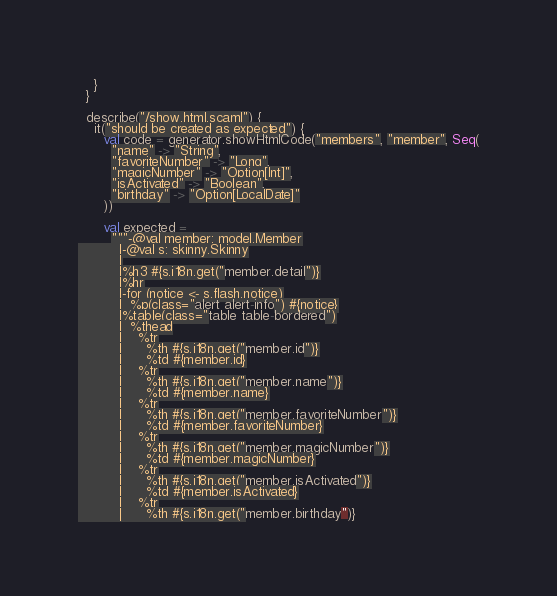<code> <loc_0><loc_0><loc_500><loc_500><_Scala_>    }
  }

  describe("/show.html.scaml") {
    it("should be created as expected") {
      val code = generator.showHtmlCode("members", "member", Seq(
        "name" -> "String",
        "favoriteNumber" -> "Long",
        "magicNumber" -> "Option[Int]",
        "isActivated" -> "Boolean",
        "birthday" -> "Option[LocalDate]"
      ))

      val expected =
        """-@val member: model.Member
          |-@val s: skinny.Skinny
          |
          |%h3 #{s.i18n.get("member.detail")}
          |%hr
          |-for (notice <- s.flash.notice)
          |  %p(class="alert alert-info") #{notice}
          |%table(class="table table-bordered")
          |  %thead
          |    %tr
          |      %th #{s.i18n.get("member.id")}
          |      %td #{member.id}
          |    %tr
          |      %th #{s.i18n.get("member.name")}
          |      %td #{member.name}
          |    %tr
          |      %th #{s.i18n.get("member.favoriteNumber")}
          |      %td #{member.favoriteNumber}
          |    %tr
          |      %th #{s.i18n.get("member.magicNumber")}
          |      %td #{member.magicNumber}
          |    %tr
          |      %th #{s.i18n.get("member.isActivated")}
          |      %td #{member.isActivated}
          |    %tr
          |      %th #{s.i18n.get("member.birthday")}</code> 